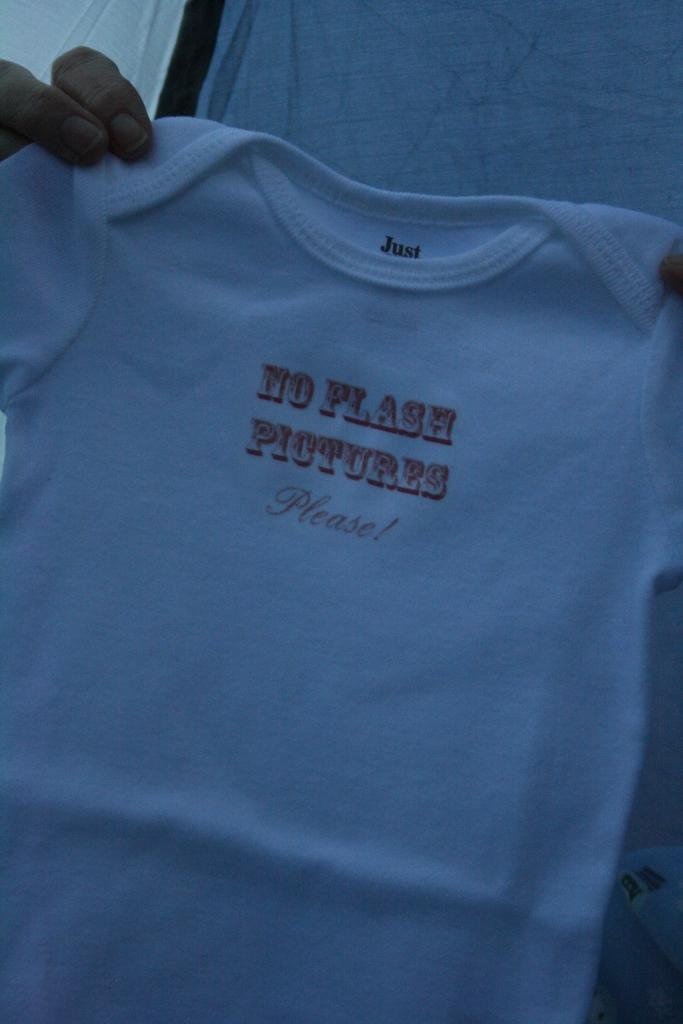<image>
Render a clear and concise summary of the photo. A shirt exclaims "no flash pictures please" on the front. 